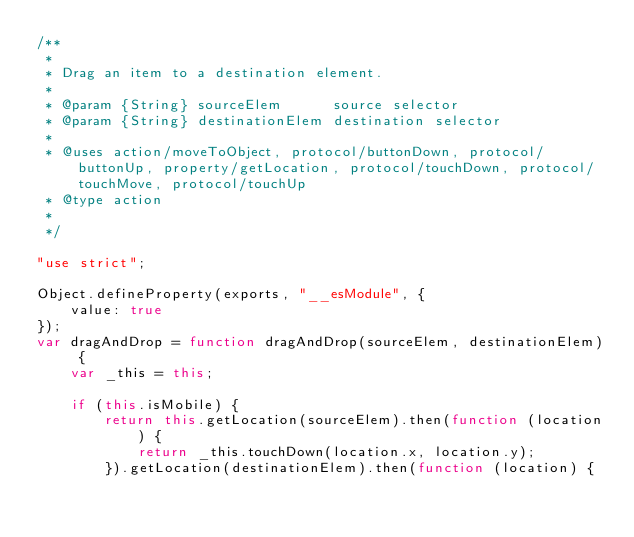Convert code to text. <code><loc_0><loc_0><loc_500><loc_500><_JavaScript_>/**
 *
 * Drag an item to a destination element.
 *
 * @param {String} sourceElem      source selector
 * @param {String} destinationElem destination selector
 *
 * @uses action/moveToObject, protocol/buttonDown, protocol/buttonUp, property/getLocation, protocol/touchDown, protocol/touchMove, protocol/touchUp
 * @type action
 *
 */

"use strict";

Object.defineProperty(exports, "__esModule", {
    value: true
});
var dragAndDrop = function dragAndDrop(sourceElem, destinationElem) {
    var _this = this;

    if (this.isMobile) {
        return this.getLocation(sourceElem).then(function (location) {
            return _this.touchDown(location.x, location.y);
        }).getLocation(destinationElem).then(function (location) {</code> 